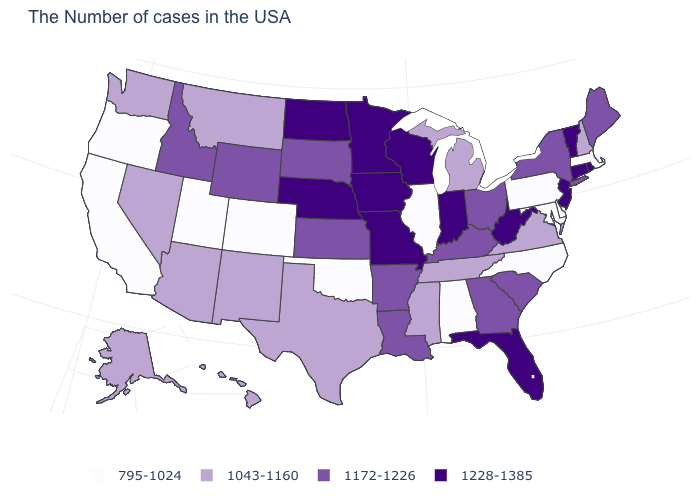What is the value of Pennsylvania?
Short answer required. 795-1024. What is the value of Rhode Island?
Concise answer only. 1228-1385. What is the value of Alaska?
Answer briefly. 1043-1160. What is the value of Alabama?
Short answer required. 795-1024. What is the highest value in states that border Maine?
Answer briefly. 1043-1160. Which states have the highest value in the USA?
Be succinct. Rhode Island, Vermont, Connecticut, New Jersey, West Virginia, Florida, Indiana, Wisconsin, Missouri, Minnesota, Iowa, Nebraska, North Dakota. Which states have the lowest value in the USA?
Give a very brief answer. Massachusetts, Delaware, Maryland, Pennsylvania, North Carolina, Alabama, Illinois, Oklahoma, Colorado, Utah, California, Oregon. Name the states that have a value in the range 795-1024?
Answer briefly. Massachusetts, Delaware, Maryland, Pennsylvania, North Carolina, Alabama, Illinois, Oklahoma, Colorado, Utah, California, Oregon. Which states have the lowest value in the Northeast?
Keep it brief. Massachusetts, Pennsylvania. What is the value of Illinois?
Write a very short answer. 795-1024. Does Wyoming have a lower value than Massachusetts?
Short answer required. No. Among the states that border North Carolina , does South Carolina have the highest value?
Short answer required. Yes. Which states have the lowest value in the West?
Be succinct. Colorado, Utah, California, Oregon. Which states have the highest value in the USA?
Give a very brief answer. Rhode Island, Vermont, Connecticut, New Jersey, West Virginia, Florida, Indiana, Wisconsin, Missouri, Minnesota, Iowa, Nebraska, North Dakota. What is the lowest value in states that border Oregon?
Short answer required. 795-1024. 